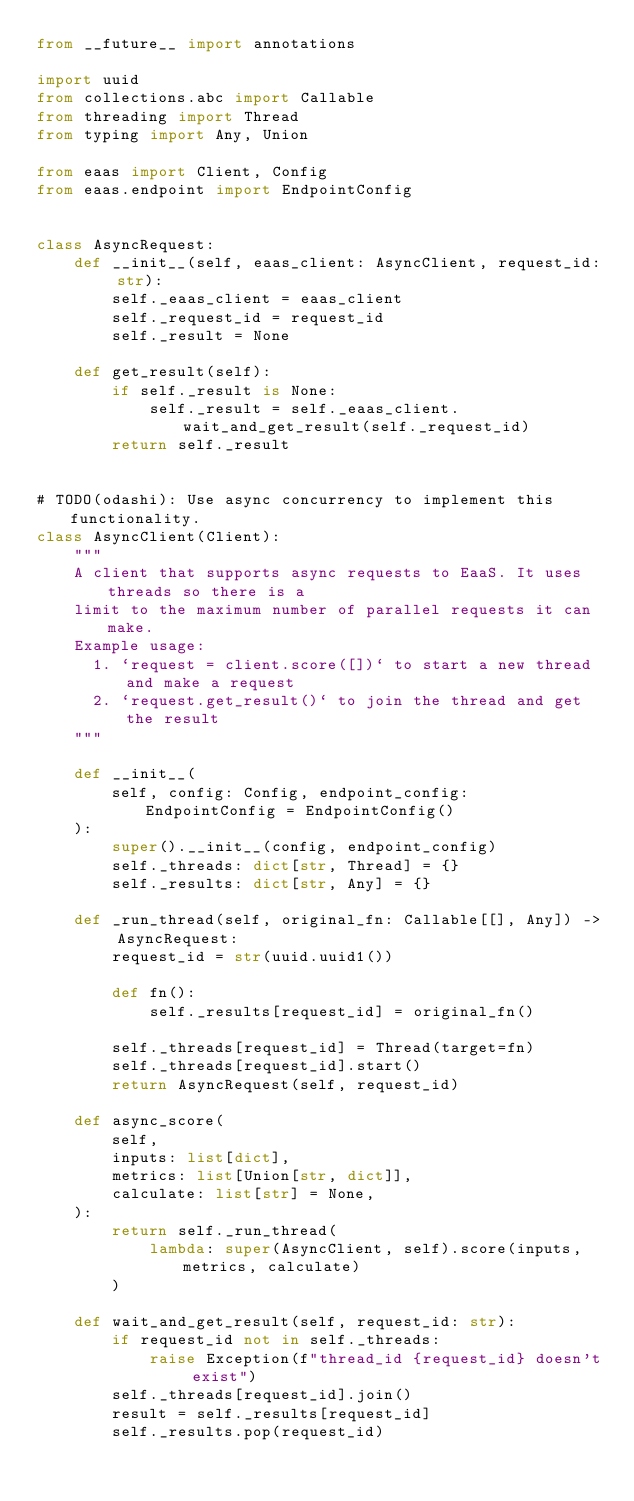<code> <loc_0><loc_0><loc_500><loc_500><_Python_>from __future__ import annotations

import uuid
from collections.abc import Callable
from threading import Thread
from typing import Any, Union

from eaas import Client, Config
from eaas.endpoint import EndpointConfig


class AsyncRequest:
    def __init__(self, eaas_client: AsyncClient, request_id: str):
        self._eaas_client = eaas_client
        self._request_id = request_id
        self._result = None

    def get_result(self):
        if self._result is None:
            self._result = self._eaas_client.wait_and_get_result(self._request_id)
        return self._result


# TODO(odashi): Use async concurrency to implement this functionality.
class AsyncClient(Client):
    """
    A client that supports async requests to EaaS. It uses threads so there is a
    limit to the maximum number of parallel requests it can make.
    Example usage:
      1. `request = client.score([])` to start a new thread and make a request
      2. `request.get_result()` to join the thread and get the result
    """

    def __init__(
        self, config: Config, endpoint_config: EndpointConfig = EndpointConfig()
    ):
        super().__init__(config, endpoint_config)
        self._threads: dict[str, Thread] = {}
        self._results: dict[str, Any] = {}

    def _run_thread(self, original_fn: Callable[[], Any]) -> AsyncRequest:
        request_id = str(uuid.uuid1())

        def fn():
            self._results[request_id] = original_fn()

        self._threads[request_id] = Thread(target=fn)
        self._threads[request_id].start()
        return AsyncRequest(self, request_id)

    def async_score(
        self,
        inputs: list[dict],
        metrics: list[Union[str, dict]],
        calculate: list[str] = None,
    ):
        return self._run_thread(
            lambda: super(AsyncClient, self).score(inputs, metrics, calculate)
        )

    def wait_and_get_result(self, request_id: str):
        if request_id not in self._threads:
            raise Exception(f"thread_id {request_id} doesn't exist")
        self._threads[request_id].join()
        result = self._results[request_id]
        self._results.pop(request_id)</code> 